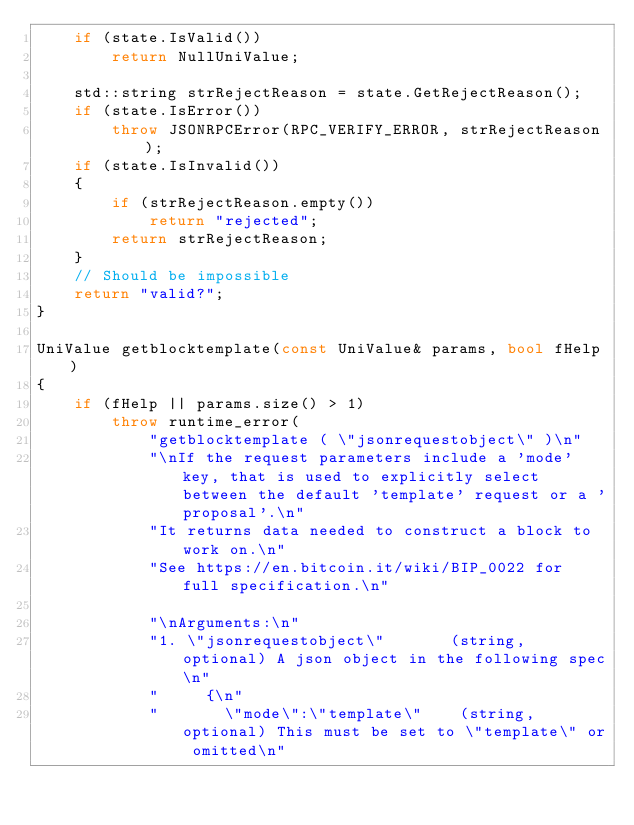Convert code to text. <code><loc_0><loc_0><loc_500><loc_500><_C++_>    if (state.IsValid())
        return NullUniValue;

    std::string strRejectReason = state.GetRejectReason();
    if (state.IsError())
        throw JSONRPCError(RPC_VERIFY_ERROR, strRejectReason);
    if (state.IsInvalid())
    {
        if (strRejectReason.empty())
            return "rejected";
        return strRejectReason;
    }
    // Should be impossible
    return "valid?";
}

UniValue getblocktemplate(const UniValue& params, bool fHelp)
{
    if (fHelp || params.size() > 1)
        throw runtime_error(
            "getblocktemplate ( \"jsonrequestobject\" )\n"
            "\nIf the request parameters include a 'mode' key, that is used to explicitly select between the default 'template' request or a 'proposal'.\n"
            "It returns data needed to construct a block to work on.\n"
            "See https://en.bitcoin.it/wiki/BIP_0022 for full specification.\n"

            "\nArguments:\n"
            "1. \"jsonrequestobject\"       (string, optional) A json object in the following spec\n"
            "     {\n"
            "       \"mode\":\"template\"    (string, optional) This must be set to \"template\" or omitted\n"</code> 